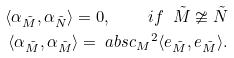Convert formula to latex. <formula><loc_0><loc_0><loc_500><loc_500>\langle \alpha _ { \tilde { M } } , \alpha _ { \tilde { N } } \rangle = 0 , \quad i f \ \tilde { M } \ncong \tilde { N } \\ \langle \alpha _ { \tilde { M } } , \alpha _ { \tilde { M } } \rangle = \ a b s { c _ { M } } ^ { 2 } \langle e _ { \tilde { M } } , e _ { \tilde { M } } \rangle .</formula> 